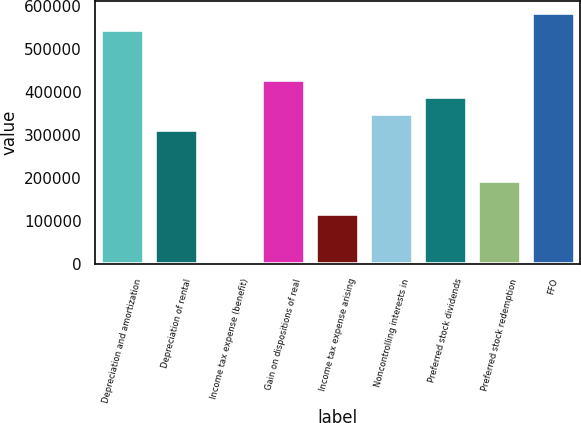<chart> <loc_0><loc_0><loc_500><loc_500><bar_chart><fcel>Depreciation and amortization<fcel>Depreciation of rental<fcel>Income tax expense (benefit)<fcel>Gain on dispositions of real<fcel>Income tax expense arising<fcel>Noncontrolling interests in<fcel>Preferred stock dividends<fcel>Preferred stock redemption<fcel>FFO<nl><fcel>545366<fcel>311645<fcel>17<fcel>428506<fcel>116878<fcel>350598<fcel>389552<fcel>194784<fcel>584320<nl></chart> 